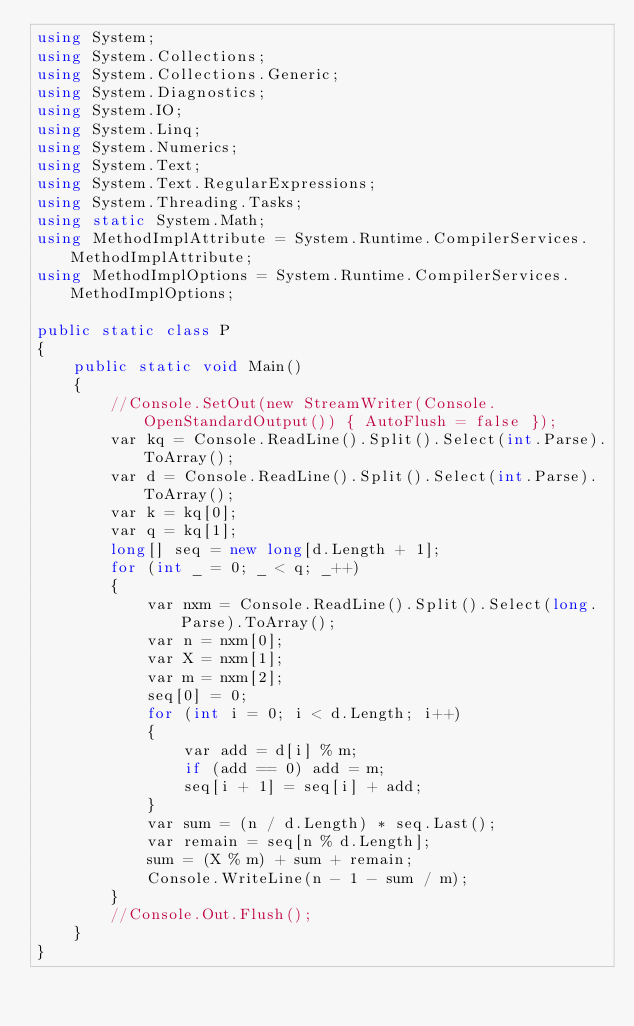<code> <loc_0><loc_0><loc_500><loc_500><_C#_>using System;
using System.Collections;
using System.Collections.Generic;
using System.Diagnostics;
using System.IO;
using System.Linq;
using System.Numerics;
using System.Text;
using System.Text.RegularExpressions;
using System.Threading.Tasks;
using static System.Math;
using MethodImplAttribute = System.Runtime.CompilerServices.MethodImplAttribute;
using MethodImplOptions = System.Runtime.CompilerServices.MethodImplOptions;

public static class P
{
    public static void Main()
    {
        //Console.SetOut(new StreamWriter(Console.OpenStandardOutput()) { AutoFlush = false });
        var kq = Console.ReadLine().Split().Select(int.Parse).ToArray();
        var d = Console.ReadLine().Split().Select(int.Parse).ToArray();
        var k = kq[0];
        var q = kq[1];
        long[] seq = new long[d.Length + 1];
        for (int _ = 0; _ < q; _++)
        {
            var nxm = Console.ReadLine().Split().Select(long.Parse).ToArray();
            var n = nxm[0];
            var X = nxm[1];
            var m = nxm[2];
            seq[0] = 0;
            for (int i = 0; i < d.Length; i++)
            {
                var add = d[i] % m;
                if (add == 0) add = m;
                seq[i + 1] = seq[i] + add;
            }
            var sum = (n / d.Length) * seq.Last();
            var remain = seq[n % d.Length];
            sum = (X % m) + sum + remain;
            Console.WriteLine(n - 1 - sum / m);
        }
        //Console.Out.Flush();
    }
}
</code> 